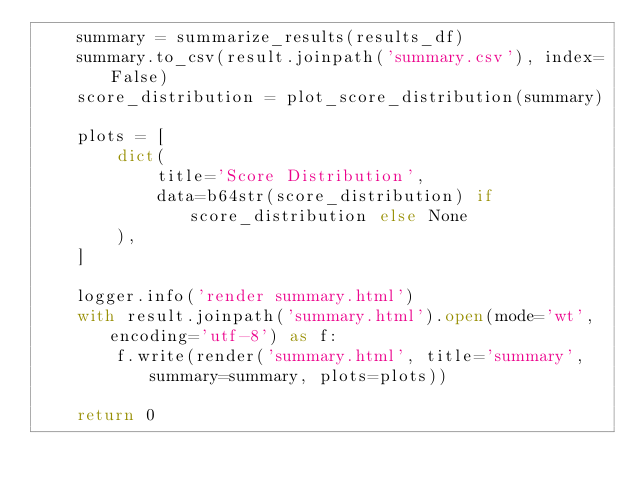<code> <loc_0><loc_0><loc_500><loc_500><_Python_>    summary = summarize_results(results_df)
    summary.to_csv(result.joinpath('summary.csv'), index=False)
    score_distribution = plot_score_distribution(summary)

    plots = [
        dict(
            title='Score Distribution',
            data=b64str(score_distribution) if score_distribution else None
        ),
    ]

    logger.info('render summary.html')
    with result.joinpath('summary.html').open(mode='wt', encoding='utf-8') as f:
        f.write(render('summary.html', title='summary', summary=summary, plots=plots))

    return 0
</code> 